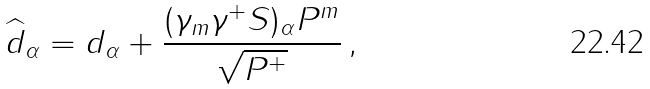<formula> <loc_0><loc_0><loc_500><loc_500>\widehat { d } _ { \alpha } = d _ { \alpha } + \frac { ( \gamma _ { m } \gamma ^ { + } S ) _ { \alpha } P ^ { m } } { \sqrt { P ^ { + } } } \, ,</formula> 